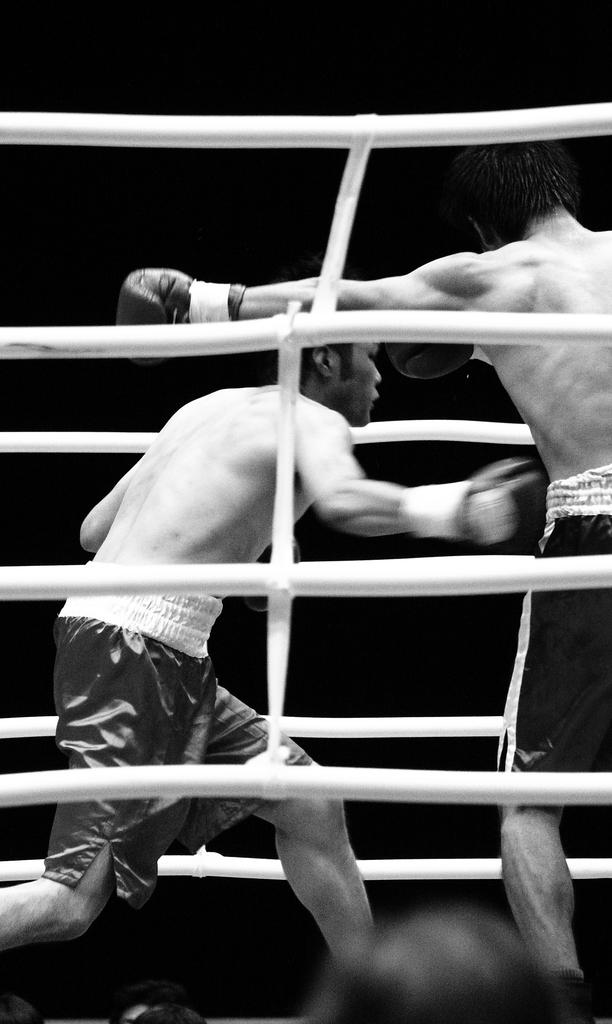How many individuals are present in the image? There are two people in the image. What can be observed about the background of the image? The background of the image is dark. What type of sail can be seen in the image? There is no sail present in the image. What musical harmony is being played by the two people in the image? There is no indication of music or harmony in the image; it only shows two people. 